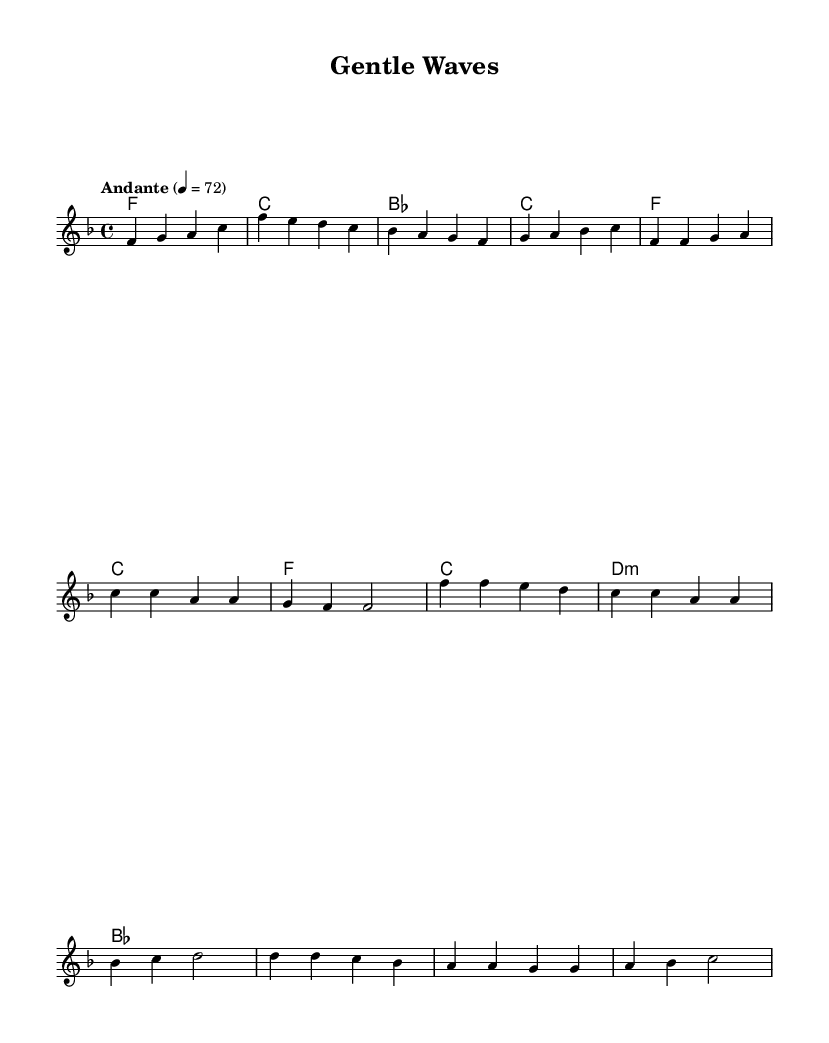What is the key signature of this music? The key signature can be found at the beginning of the score. In this case, it shows one flat, indicating that this piece is in F major.
Answer: F major What is the time signature of this music? The time signature is located at the beginning of the score, which shows "4/4," meaning there are four beats in each measure.
Answer: 4/4 What tempo marking is indicated in this music? The tempo marking is typically found near the beginning of the score. Here, it specifies "Andante," which indicates a moderate pace.
Answer: Andante What is the first chord played in the intro? The first chord can be determined from the chord notations at the start of the score. The intro begins with the chord of F major.
Answer: F How many measures are in the chorus section? To find the number of measures in the chorus, we can count the measures specifically listed under the "Chorus" section in the melody. There are four measures present.
Answer: 4 What type of musical piece is this? The structure of the music, including its key signature, tempo, and soft nature, suggests it is a ballad, which is common in K-Pop for expressing emotions and relaxation.
Answer: Ballad What is the last chord in the bridge section? The last chord can be identified by looking at the chord notations for the bridge section. The final chord listed is B-flat major.
Answer: B-flat 